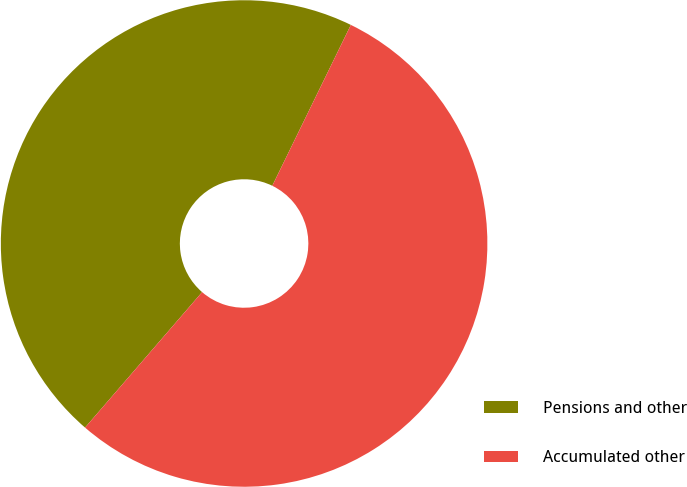<chart> <loc_0><loc_0><loc_500><loc_500><pie_chart><fcel>Pensions and other<fcel>Accumulated other<nl><fcel>45.89%<fcel>54.11%<nl></chart> 